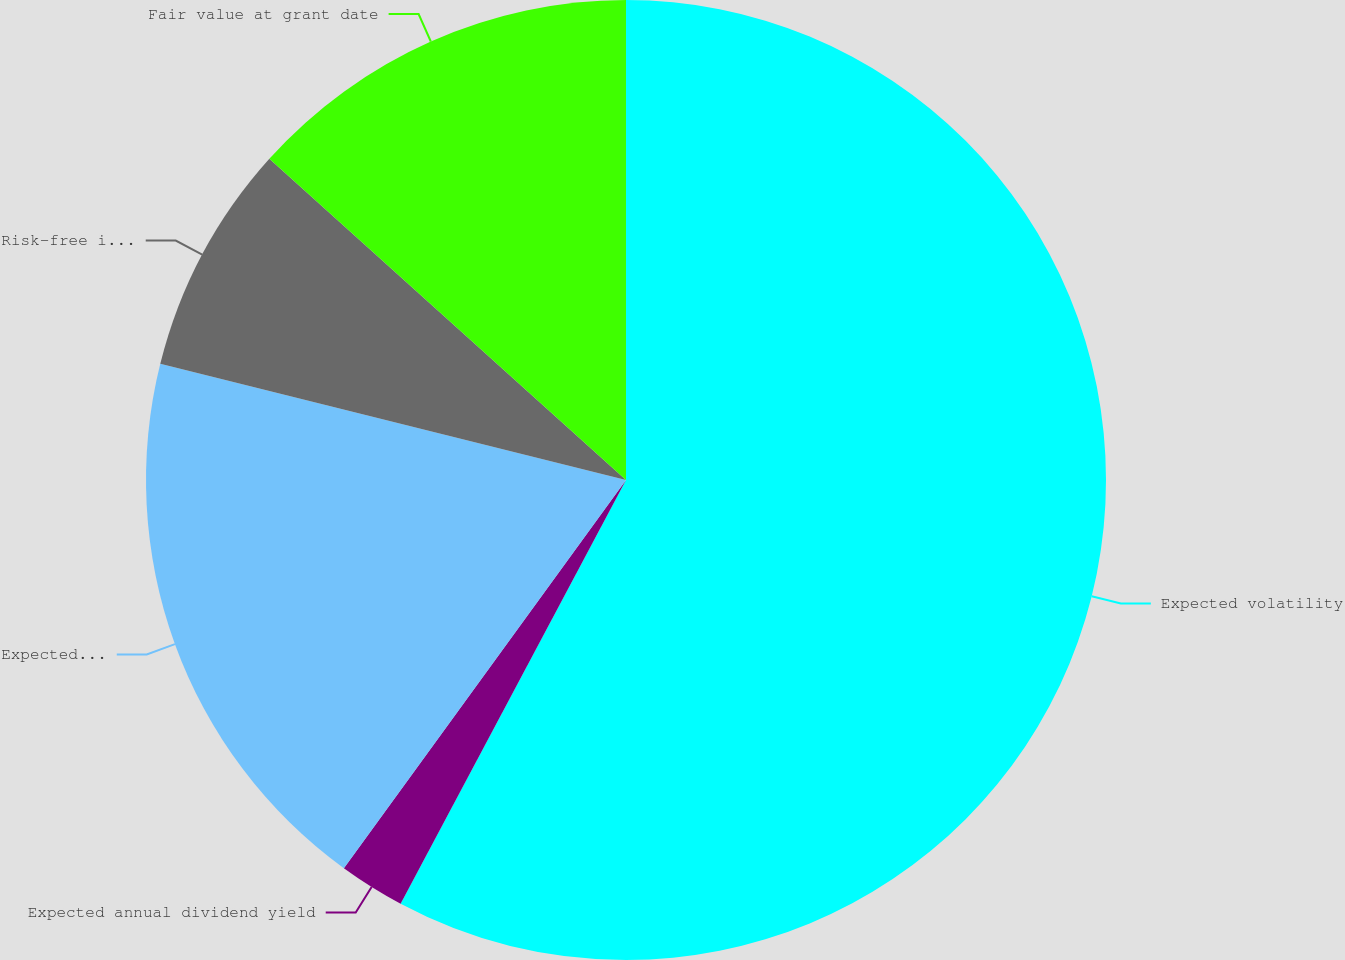<chart> <loc_0><loc_0><loc_500><loc_500><pie_chart><fcel>Expected volatility<fcel>Expected annual dividend yield<fcel>Expected option term (years)<fcel>Risk-free interest rate<fcel>Fair value at grant date<nl><fcel>57.78%<fcel>2.22%<fcel>18.89%<fcel>7.78%<fcel>13.33%<nl></chart> 